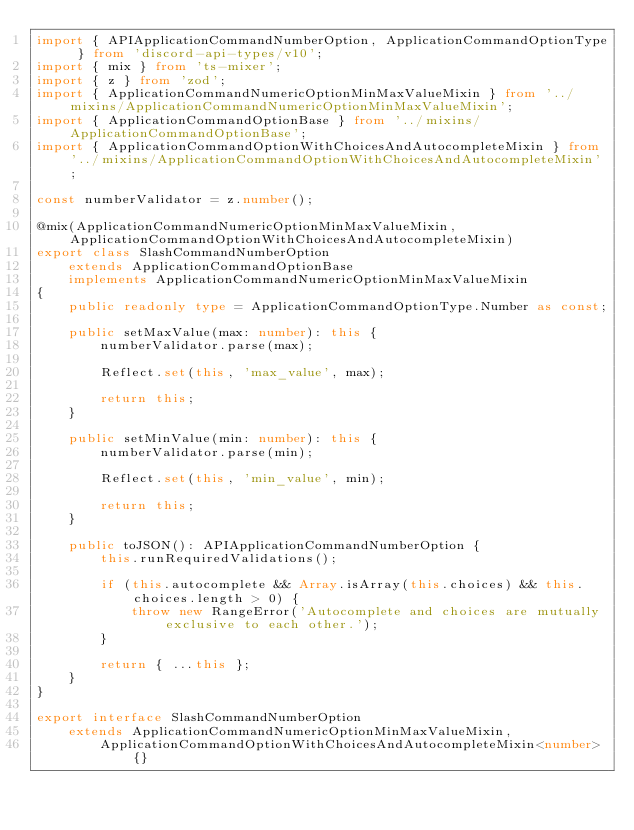<code> <loc_0><loc_0><loc_500><loc_500><_TypeScript_>import { APIApplicationCommandNumberOption, ApplicationCommandOptionType } from 'discord-api-types/v10';
import { mix } from 'ts-mixer';
import { z } from 'zod';
import { ApplicationCommandNumericOptionMinMaxValueMixin } from '../mixins/ApplicationCommandNumericOptionMinMaxValueMixin';
import { ApplicationCommandOptionBase } from '../mixins/ApplicationCommandOptionBase';
import { ApplicationCommandOptionWithChoicesAndAutocompleteMixin } from '../mixins/ApplicationCommandOptionWithChoicesAndAutocompleteMixin';

const numberValidator = z.number();

@mix(ApplicationCommandNumericOptionMinMaxValueMixin, ApplicationCommandOptionWithChoicesAndAutocompleteMixin)
export class SlashCommandNumberOption
	extends ApplicationCommandOptionBase
	implements ApplicationCommandNumericOptionMinMaxValueMixin
{
	public readonly type = ApplicationCommandOptionType.Number as const;

	public setMaxValue(max: number): this {
		numberValidator.parse(max);

		Reflect.set(this, 'max_value', max);

		return this;
	}

	public setMinValue(min: number): this {
		numberValidator.parse(min);

		Reflect.set(this, 'min_value', min);

		return this;
	}

	public toJSON(): APIApplicationCommandNumberOption {
		this.runRequiredValidations();

		if (this.autocomplete && Array.isArray(this.choices) && this.choices.length > 0) {
			throw new RangeError('Autocomplete and choices are mutually exclusive to each other.');
		}

		return { ...this };
	}
}

export interface SlashCommandNumberOption
	extends ApplicationCommandNumericOptionMinMaxValueMixin,
		ApplicationCommandOptionWithChoicesAndAutocompleteMixin<number> {}
</code> 